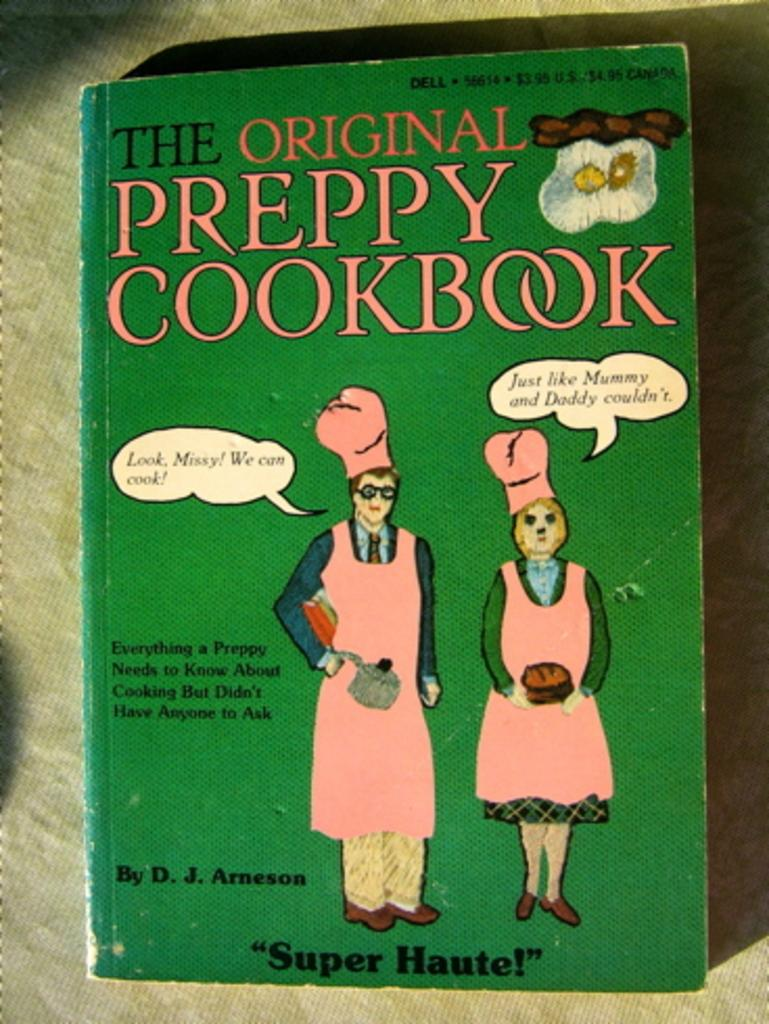<image>
Describe the image concisely. A green book with the text: "The original preppy cookbook" is shown. 